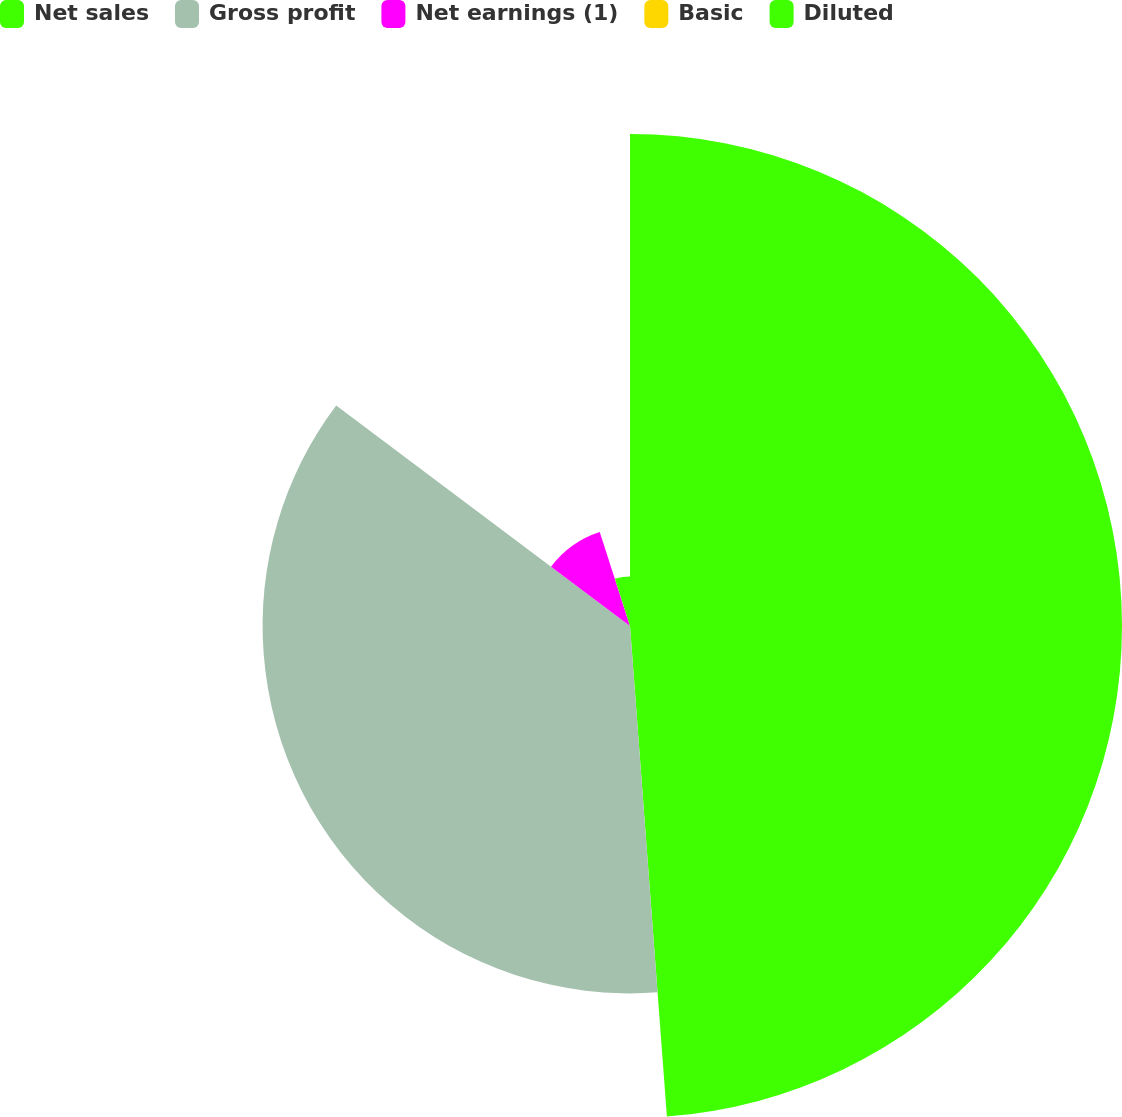Convert chart to OTSL. <chart><loc_0><loc_0><loc_500><loc_500><pie_chart><fcel>Net sales<fcel>Gross profit<fcel>Net earnings (1)<fcel>Basic<fcel>Diluted<nl><fcel>48.8%<fcel>36.44%<fcel>9.79%<fcel>0.04%<fcel>4.92%<nl></chart> 